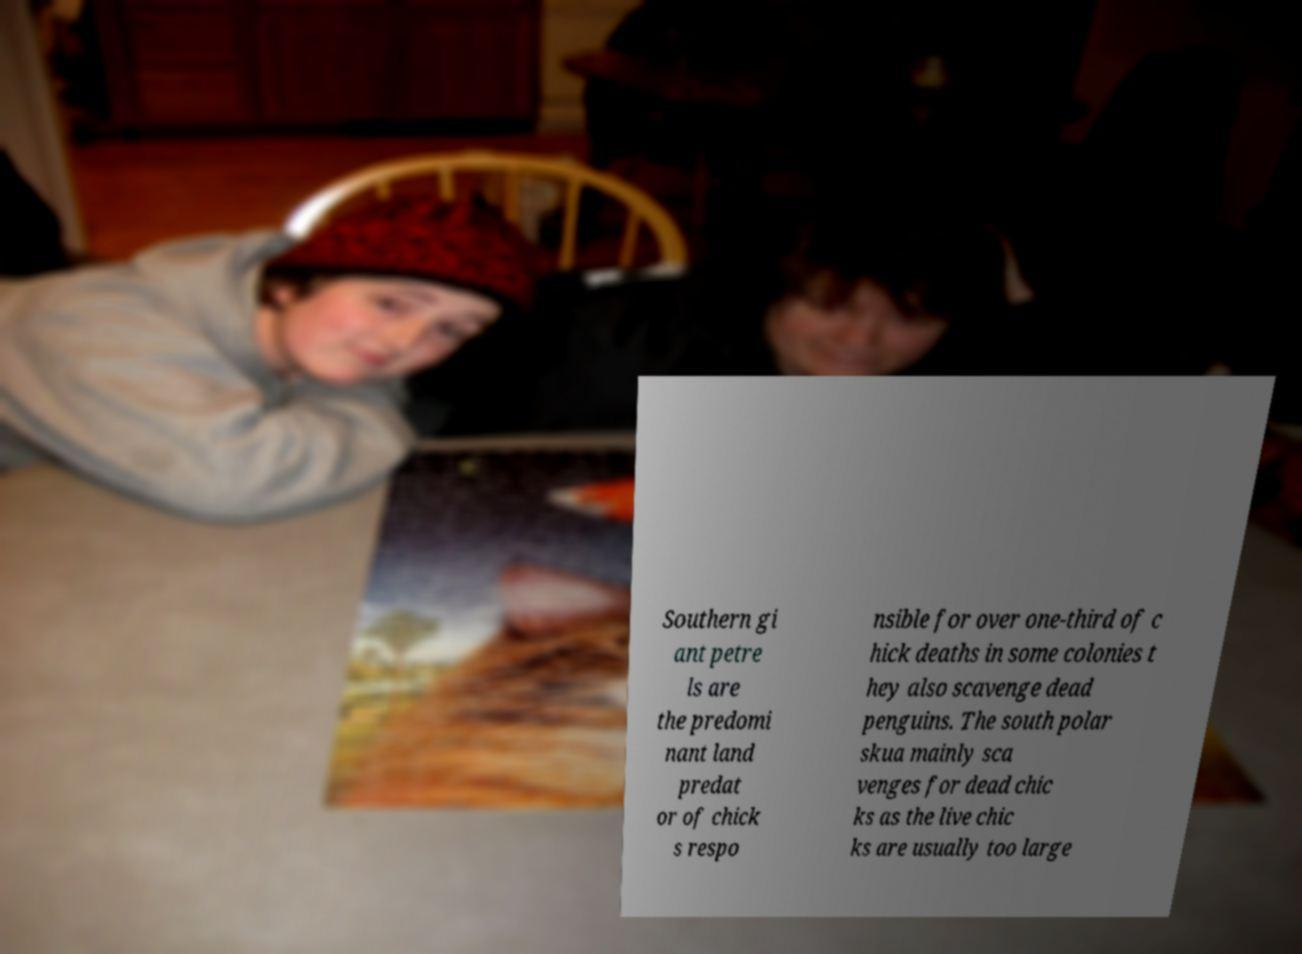I need the written content from this picture converted into text. Can you do that? Southern gi ant petre ls are the predomi nant land predat or of chick s respo nsible for over one-third of c hick deaths in some colonies t hey also scavenge dead penguins. The south polar skua mainly sca venges for dead chic ks as the live chic ks are usually too large 